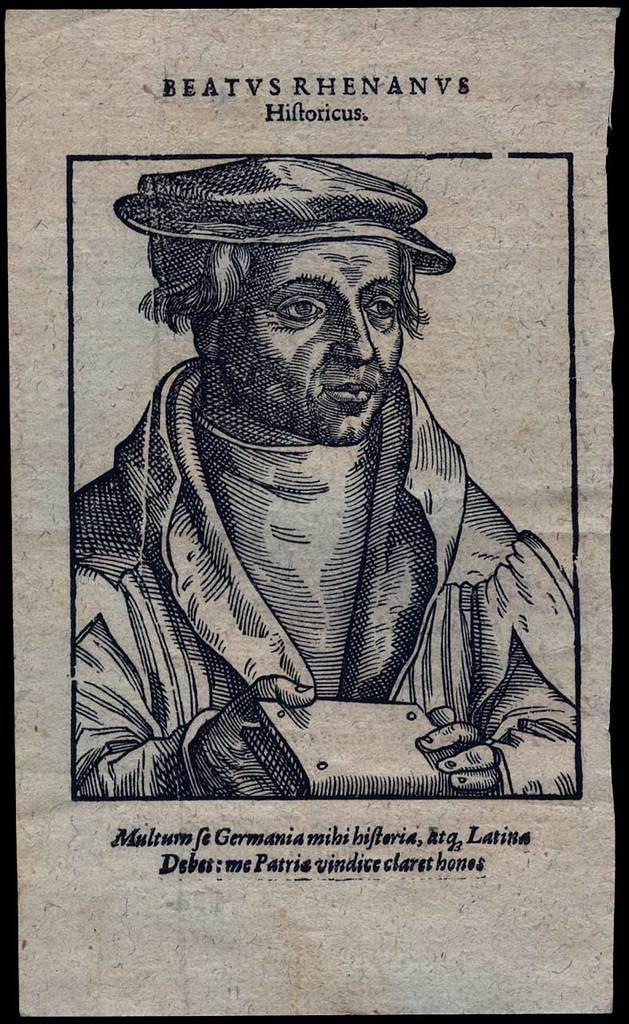Describe this image in one or two sentences. This is a drawing of a person wearing cap and holding a book. Also something is written on the image. 